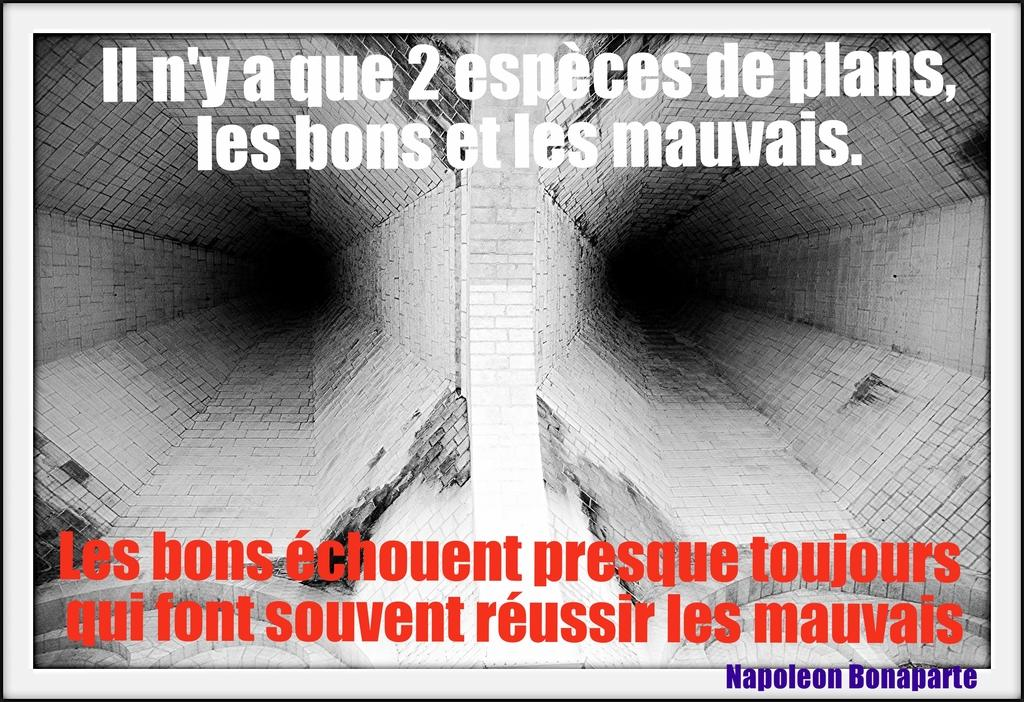Provide a one-sentence caption for the provided image. A sign in French is saying something about Napoleon. 